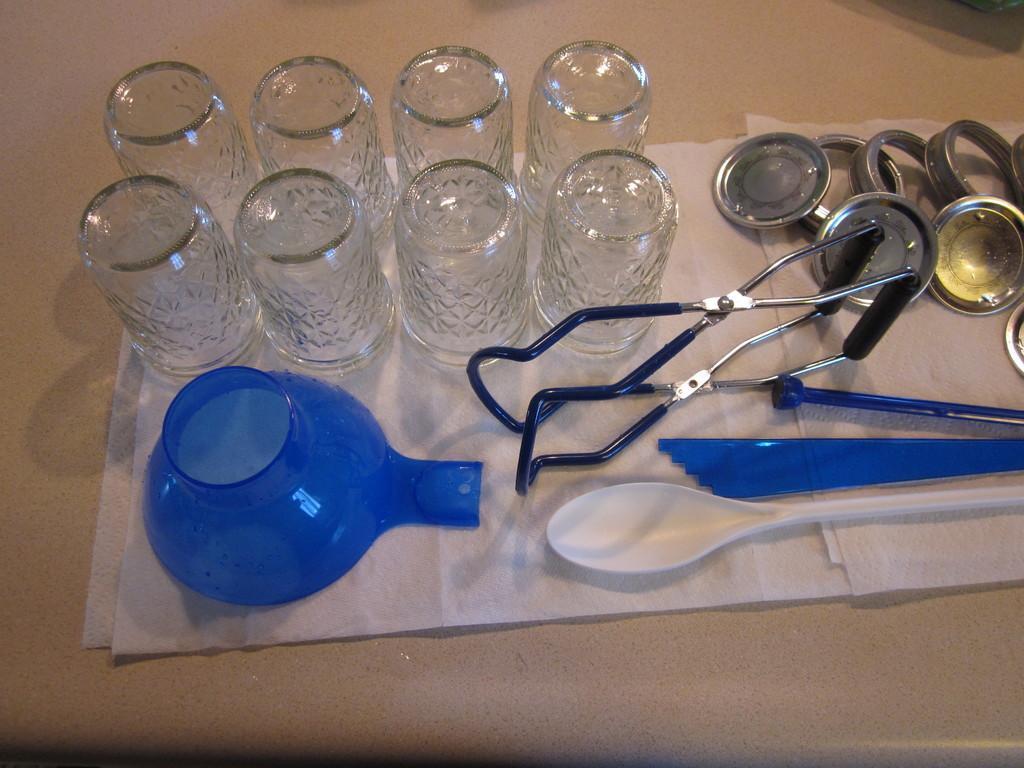Can you describe this image briefly? In this image we can see a glasses,bowl,spoon and some vessels. 